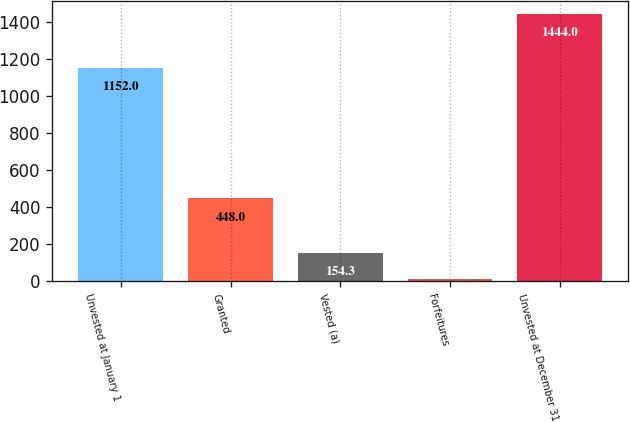Convert chart to OTSL. <chart><loc_0><loc_0><loc_500><loc_500><bar_chart><fcel>Unvested at January 1<fcel>Granted<fcel>Vested (a)<fcel>Forfeitures<fcel>Unvested at December 31<nl><fcel>1152<fcel>448<fcel>154.3<fcel>11<fcel>1444<nl></chart> 